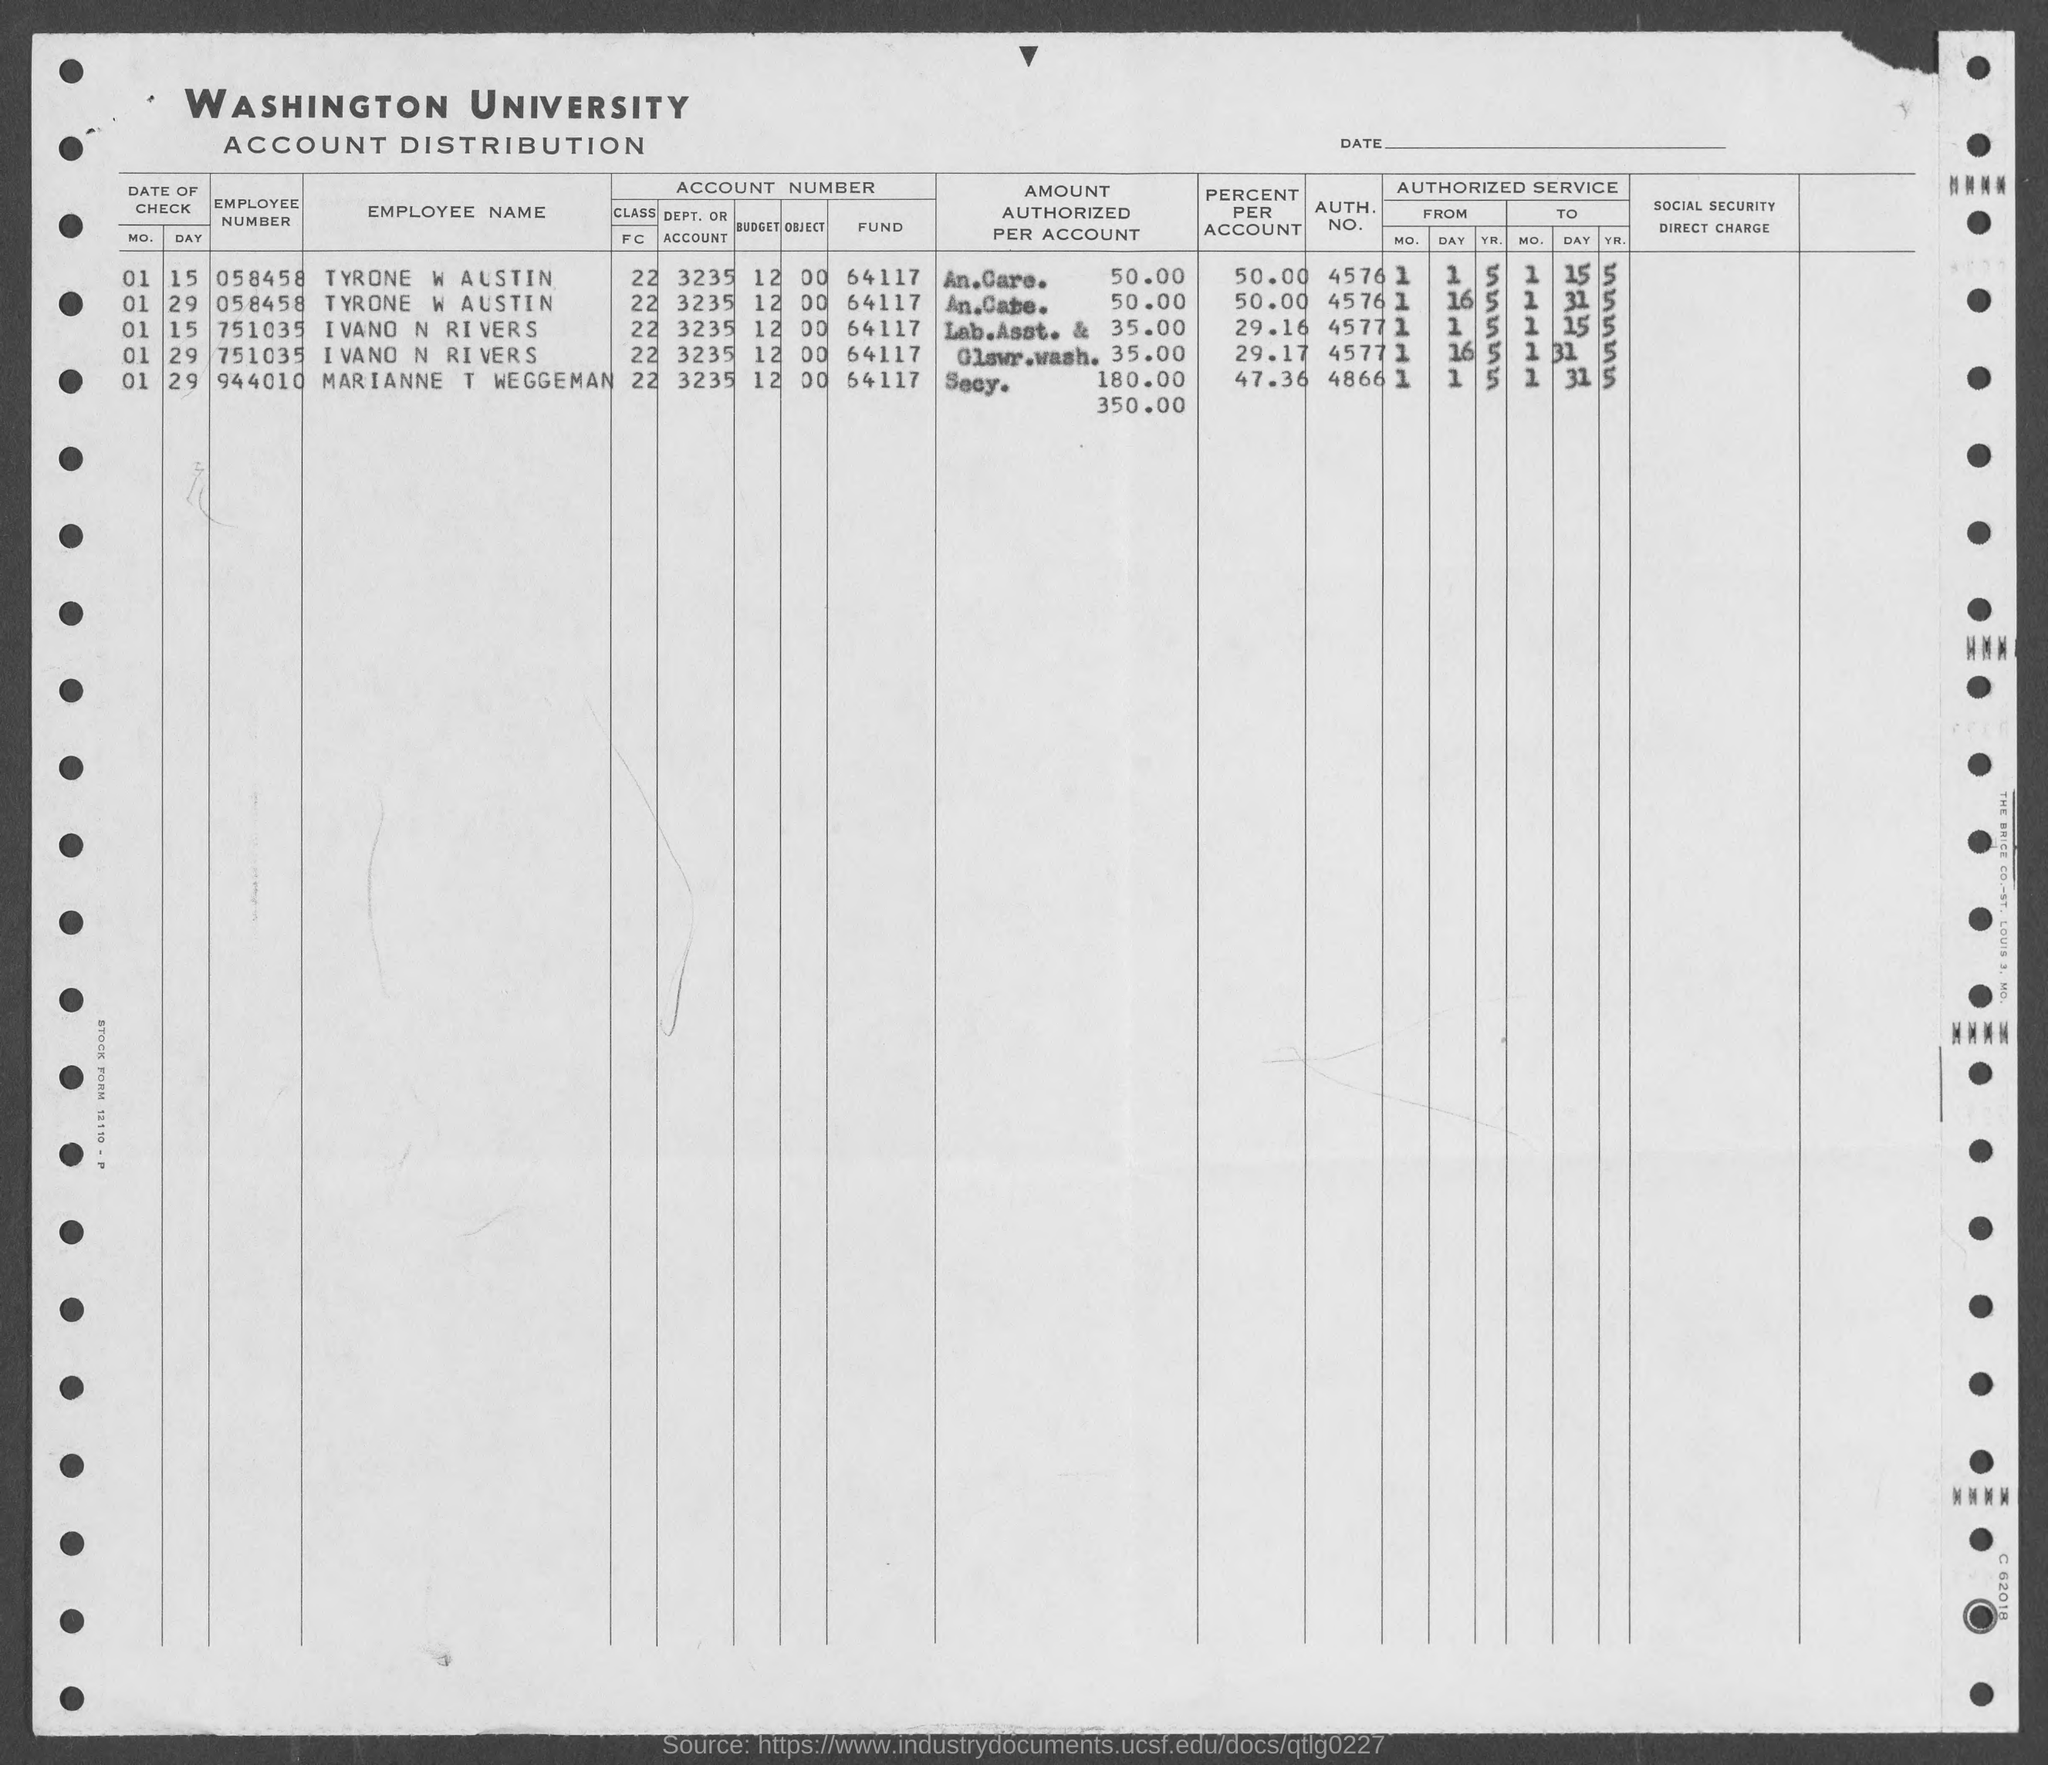Highlight a few significant elements in this photo. The Washington University is the name of the university mentioned in the given form. The author is asking for the authentication number for Tyrone W. Austin that was mentioned in the provided form. The authentication number for Ivano N Rivers as mentioned in the provided form is 4577... The employee number assigned to Marianne T. Waggeman, as mentioned in the provided form, is 944010.... The value of the percent per account for Marianne T. Waggeman, as mentioned in the given form, is 47.36... 